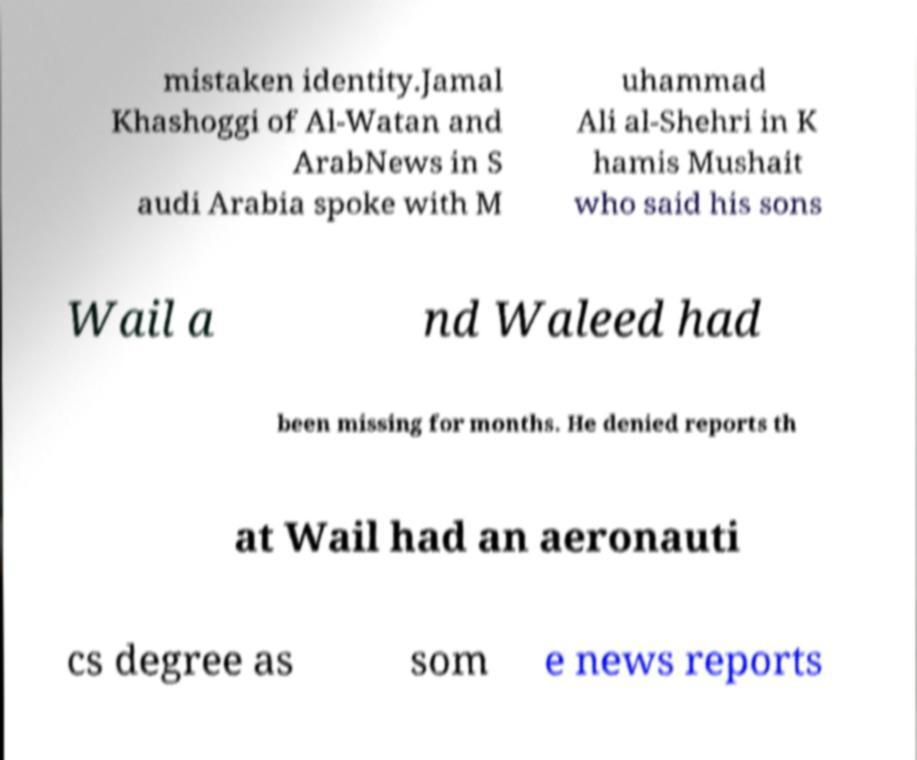I need the written content from this picture converted into text. Can you do that? mistaken identity.Jamal Khashoggi of Al-Watan and ArabNews in S audi Arabia spoke with M uhammad Ali al-Shehri in K hamis Mushait who said his sons Wail a nd Waleed had been missing for months. He denied reports th at Wail had an aeronauti cs degree as som e news reports 